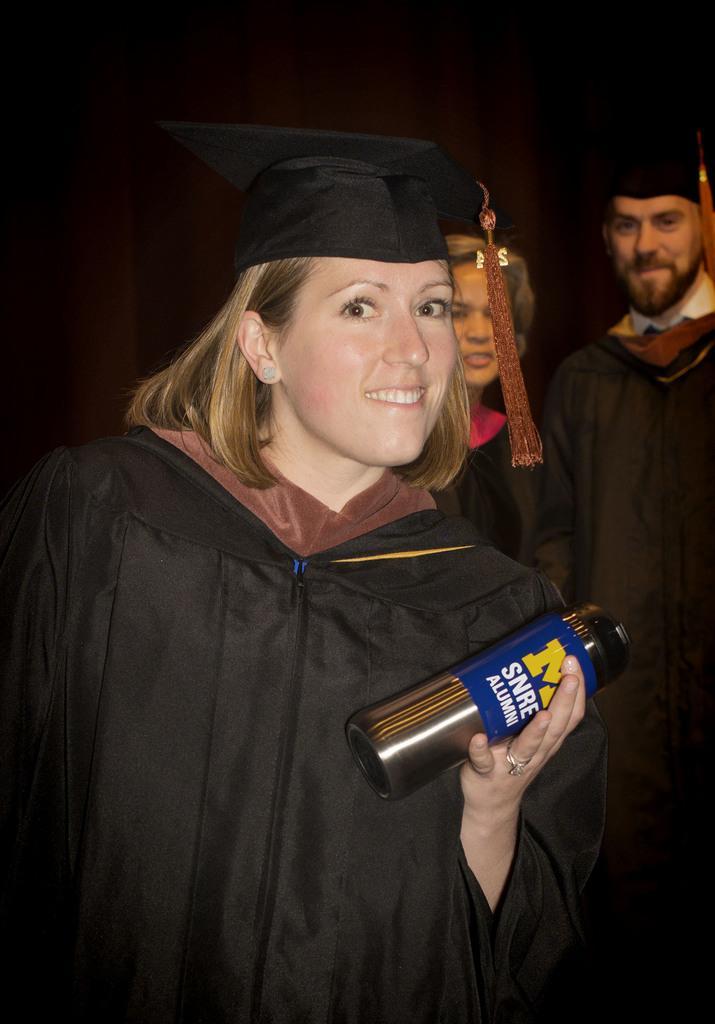Could you give a brief overview of what you see in this image? In this image the background is dark and on the left side of the image there is a woman standing and she is holding a bottle in her hand. On the right side of the image there is a man and a woman standing on the floor. 